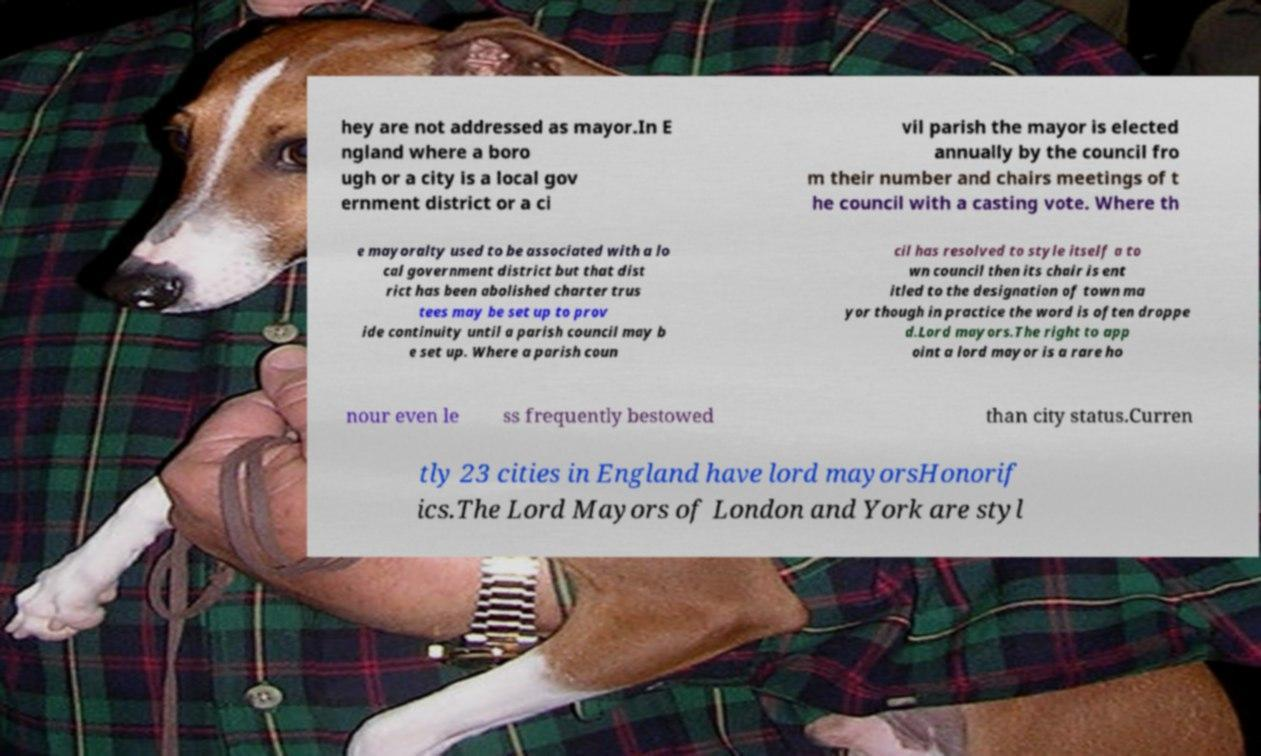There's text embedded in this image that I need extracted. Can you transcribe it verbatim? hey are not addressed as mayor.In E ngland where a boro ugh or a city is a local gov ernment district or a ci vil parish the mayor is elected annually by the council fro m their number and chairs meetings of t he council with a casting vote. Where th e mayoralty used to be associated with a lo cal government district but that dist rict has been abolished charter trus tees may be set up to prov ide continuity until a parish council may b e set up. Where a parish coun cil has resolved to style itself a to wn council then its chair is ent itled to the designation of town ma yor though in practice the word is often droppe d.Lord mayors.The right to app oint a lord mayor is a rare ho nour even le ss frequently bestowed than city status.Curren tly 23 cities in England have lord mayorsHonorif ics.The Lord Mayors of London and York are styl 